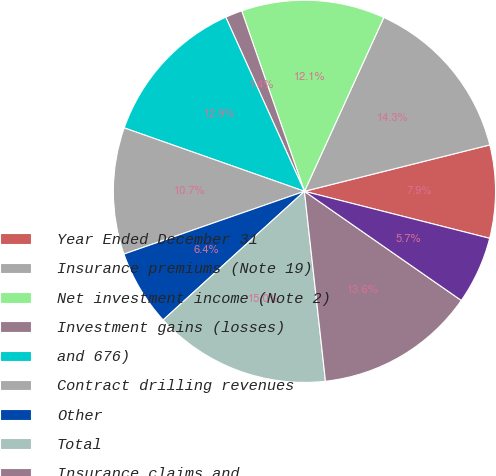<chart> <loc_0><loc_0><loc_500><loc_500><pie_chart><fcel>Year Ended December 31<fcel>Insurance premiums (Note 19)<fcel>Net investment income (Note 2)<fcel>Investment gains (losses)<fcel>and 676)<fcel>Contract drilling revenues<fcel>Other<fcel>Total<fcel>Insurance claims and<fcel>Amortization of deferred<nl><fcel>7.86%<fcel>14.28%<fcel>12.14%<fcel>1.43%<fcel>12.86%<fcel>10.71%<fcel>6.43%<fcel>15.0%<fcel>13.57%<fcel>5.72%<nl></chart> 